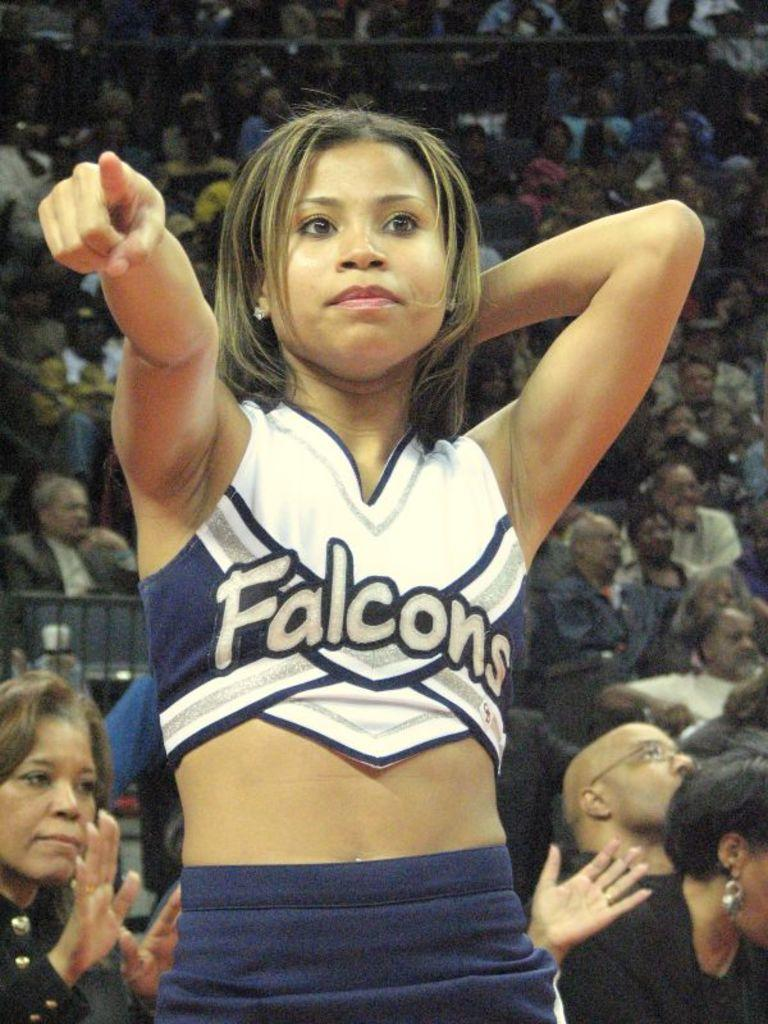Provide a one-sentence caption for the provided image. a cheerleader that has the word falcons on it. 